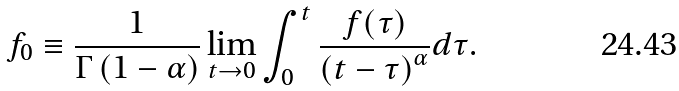<formula> <loc_0><loc_0><loc_500><loc_500>f _ { 0 } \equiv \frac { 1 } { \Gamma \left ( 1 - \alpha \right ) } \lim _ { t \to 0 } \int _ { 0 } ^ { t } \frac { f ( \tau ) } { \left ( t - \tau \right ) ^ { \alpha } } d \tau .</formula> 